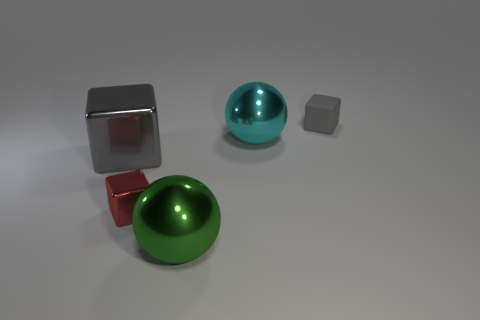What number of other objects have the same color as the rubber object?
Provide a succinct answer. 1. Do the big metal block and the small cube that is to the right of the big green metal thing have the same color?
Ensure brevity in your answer.  Yes. There is a gray cube on the right side of the big gray metal cube; what is its material?
Offer a very short reply. Rubber. How many objects are objects in front of the cyan thing or red objects?
Offer a terse response. 3. What number of other objects are the same shape as the tiny rubber object?
Your answer should be very brief. 2. Is the shape of the small object that is to the right of the small red metallic cube the same as  the tiny red metal thing?
Your answer should be compact. Yes. Are there any large metallic things on the left side of the green ball?
Keep it short and to the point. Yes. What number of large things are red cubes or red matte balls?
Provide a short and direct response. 0. Are the tiny gray block and the red object made of the same material?
Ensure brevity in your answer.  No. What size is the shiny cube that is the same color as the matte block?
Provide a succinct answer. Large. 